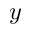<formula> <loc_0><loc_0><loc_500><loc_500>y</formula> 